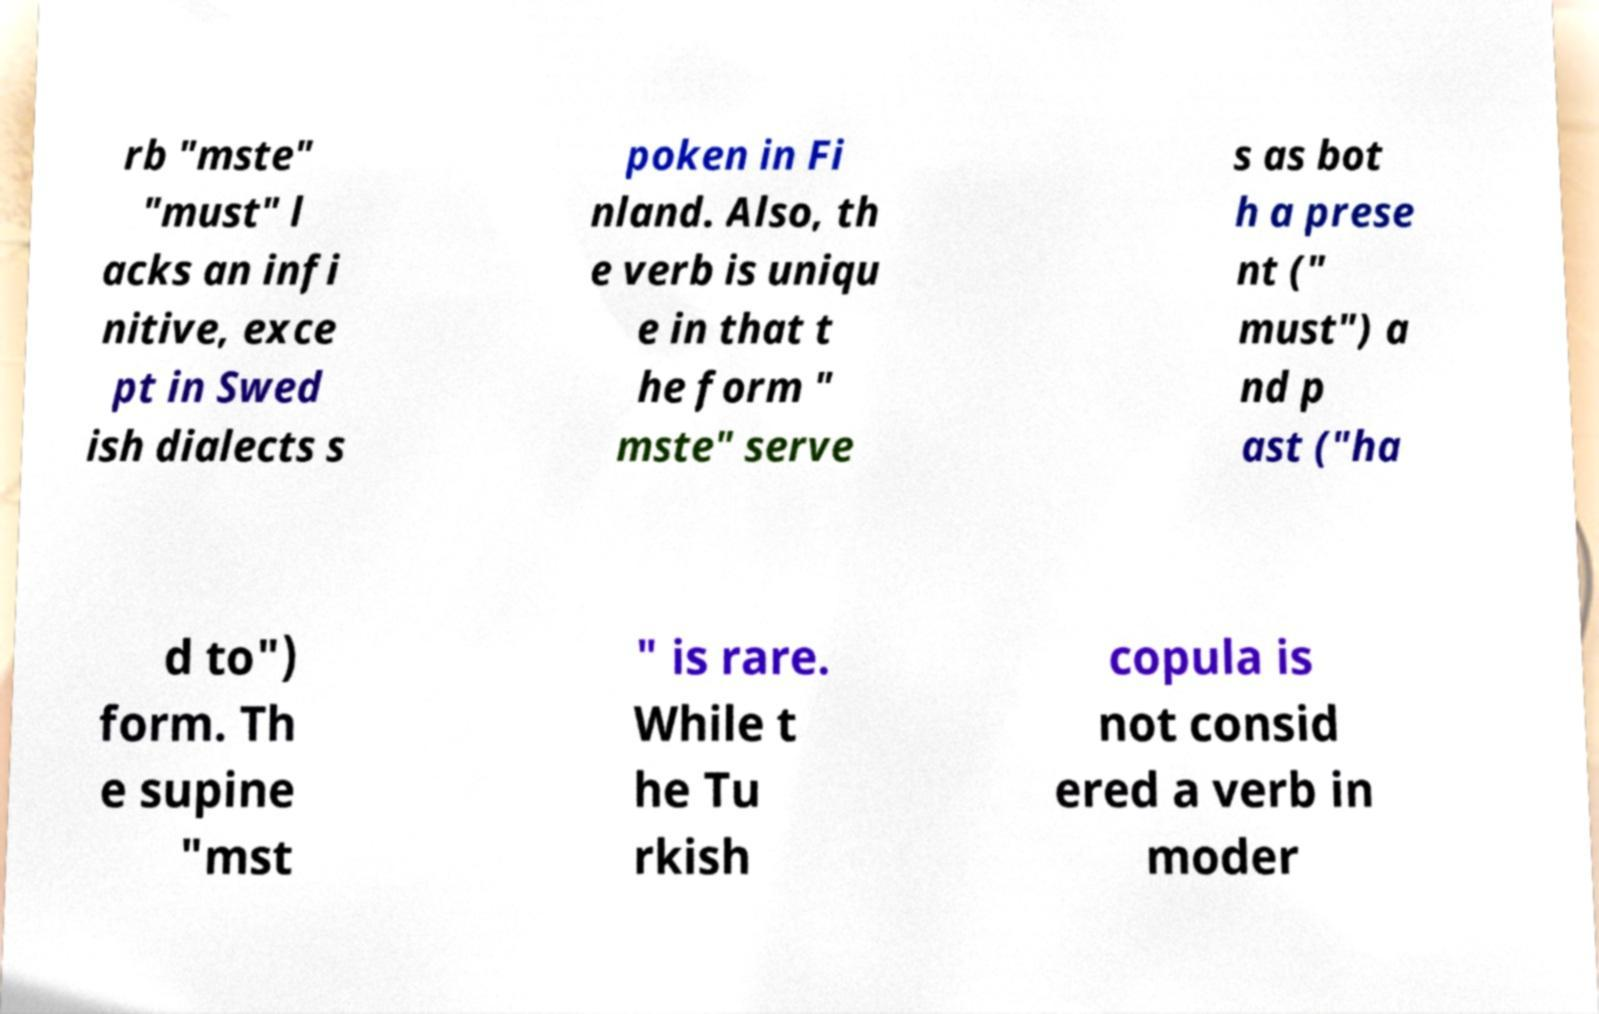Can you read and provide the text displayed in the image?This photo seems to have some interesting text. Can you extract and type it out for me? rb "mste" "must" l acks an infi nitive, exce pt in Swed ish dialects s poken in Fi nland. Also, th e verb is uniqu e in that t he form " mste" serve s as bot h a prese nt (" must") a nd p ast ("ha d to") form. Th e supine "mst " is rare. While t he Tu rkish copula is not consid ered a verb in moder 